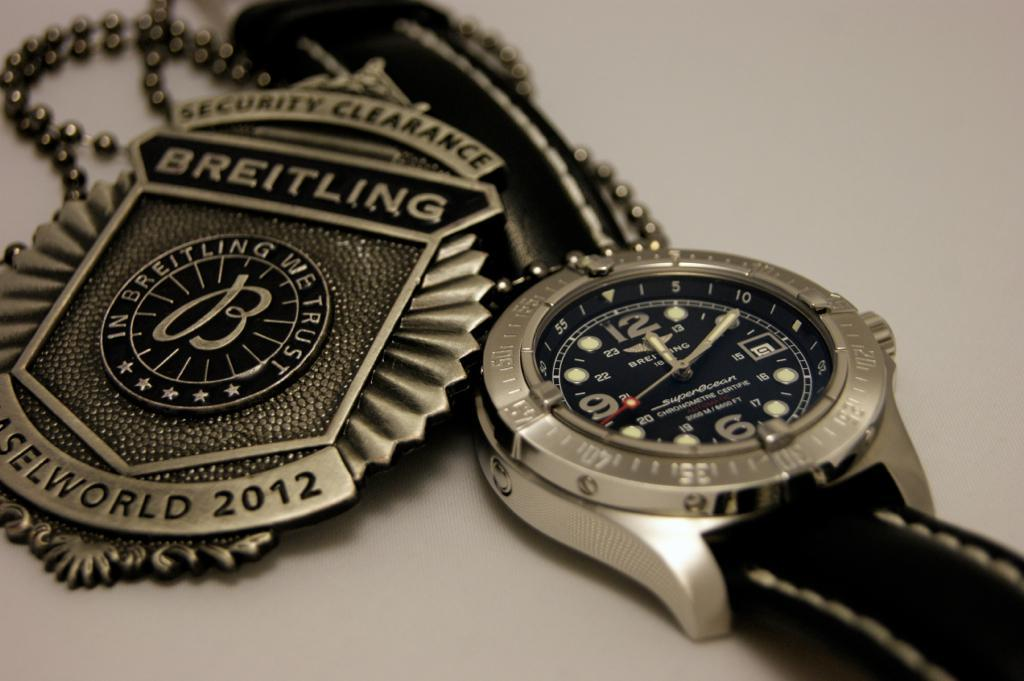<image>
Render a clear and concise summary of the photo. Wristwatch next to a logo which says Breitling on it. 